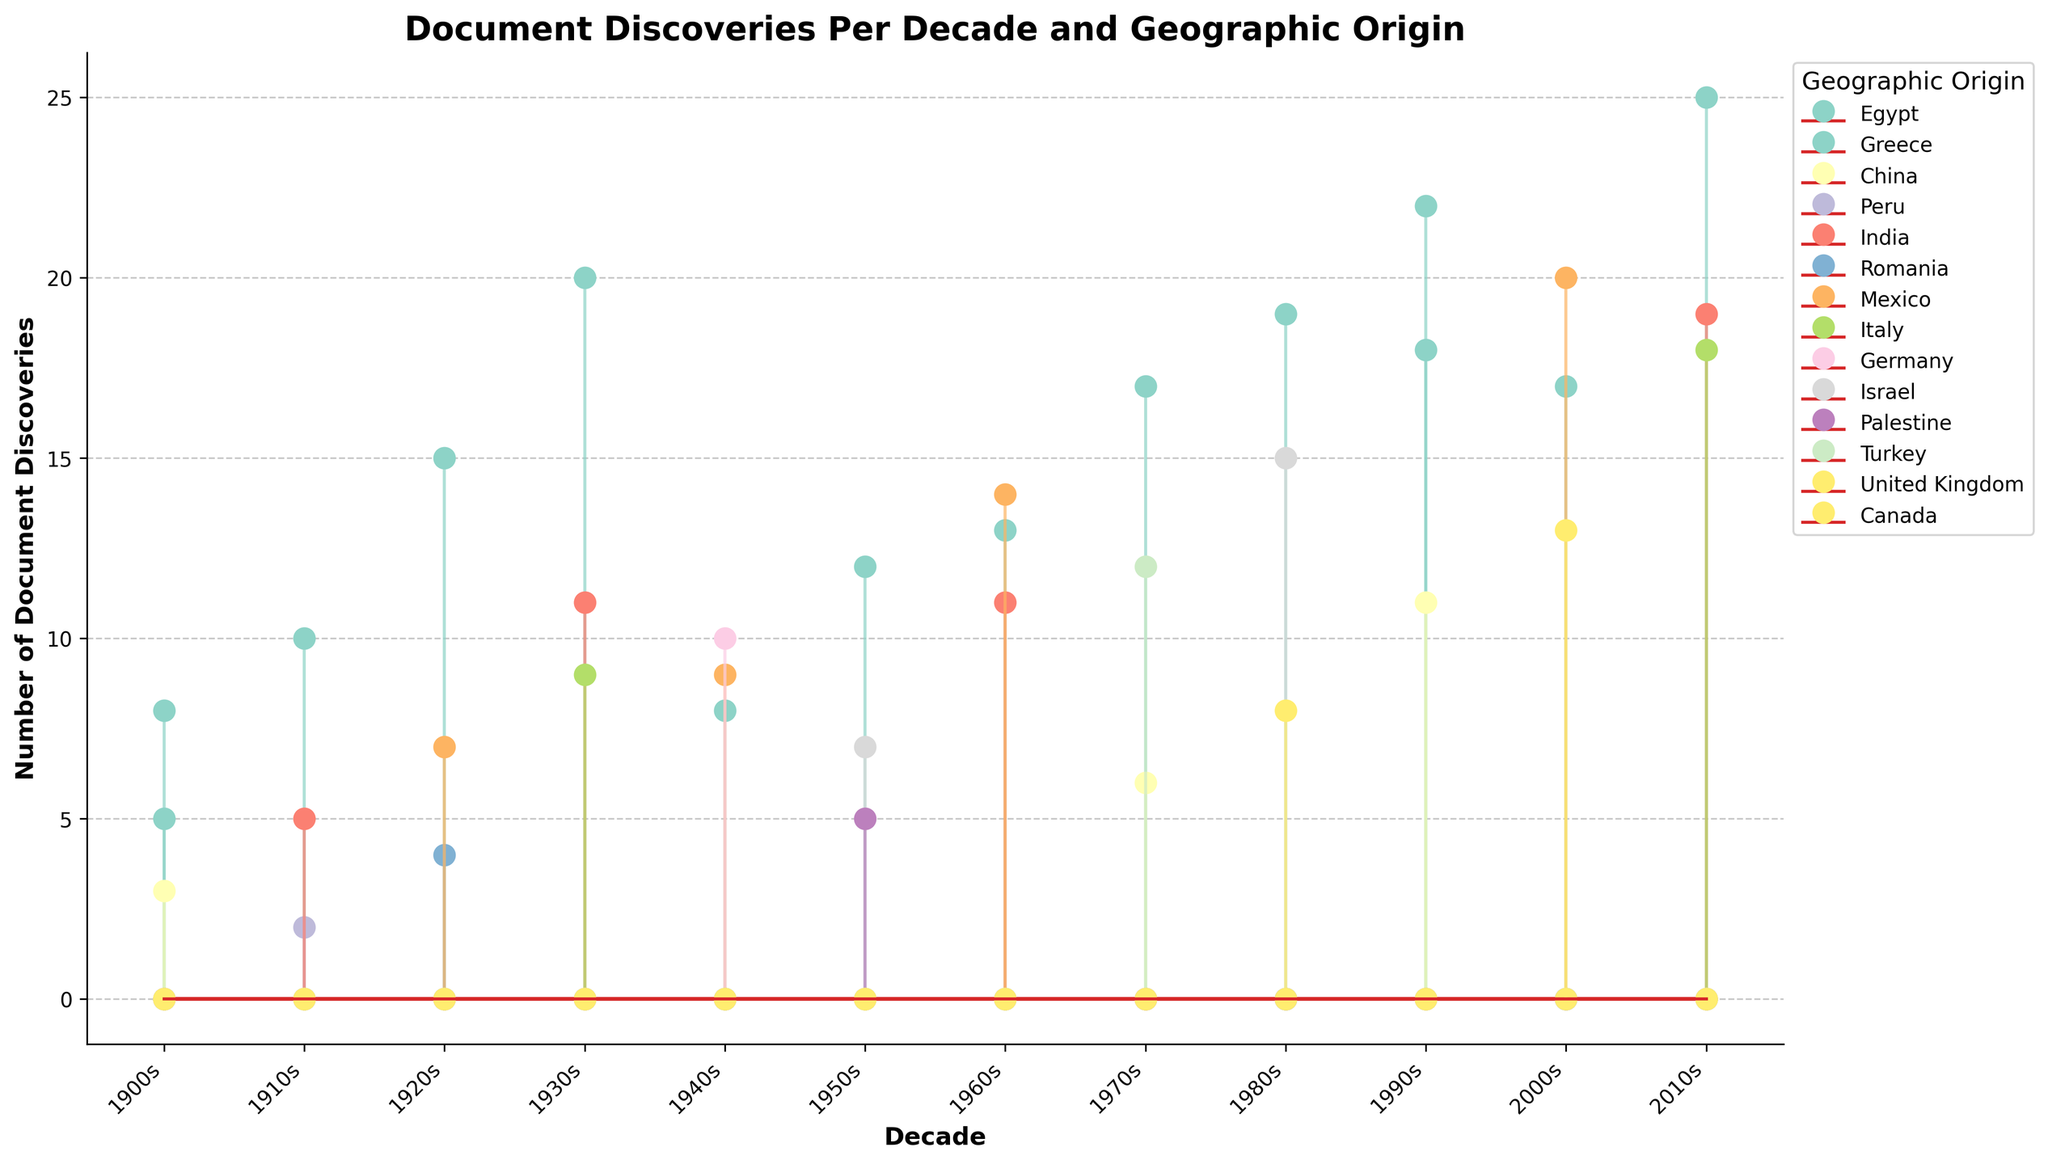When was the highest number of document discoveries made? The highest number of document discoveries is found by looking at the tallest stem across all decades. The tallest stem corresponds to the 2010s.
Answer: 2010s Which geographic origin had the most document discoveries in the 1980s? To find the origin with the most discoveries in the 1980s, observe the stems for the 1980s and identify the highest stem. The highest stem in the 1980s belongs to Egypt.
Answer: Egypt How many document discoveries were found in Egypt in the 1990s? To determine the number of document discoveries in Egypt in the 1990s, look at the specific stem for Egypt in the 1990s. The height of the stem indicates 22 discoveries.
Answer: 22 Which decade saw a greater number of discoveries in Mexico, the 1940s or the 1960s? Compare the height of the stems for Mexico in the 1940s and the 1960s. The 1960s has a higher stem for Mexico (14) compared to the 1940s (9).
Answer: 1960s How many geographic origins are represented in the 1920s? Count the number of different colored stems for the 1920s. There are four origins represented: Egypt, Romania, Mexico, and Greece.
Answer: 4 What is the total number of document discoveries in the 2000s? Sum the heights of all stems in the 2000s. Adding discoveries from Egypt (17), Mexico (20), and Canada (13) results in 50 total discoveries.
Answer: 50 Which geographic origin contributed the least number of document discoveries in the 1910s? Identify the shortest stem for the 1910s. Peru has the shortest stem with 2 discoveries.
Answer: Peru Observing the trend, which geographic origin seems to have a steadily increasing number of discoveries each decade? Examine the pattern of stems across decades for each origin. Egypt shows a general increasing trend (e.g., 20 in the 1930s, 25 in the 2010s).
Answer: Egypt By how much did the number of document discoveries in India change from the 1910s to the 2010s? Calculate the difference in the stem height for India between the 1910s (5) and the 2010s (19). The change is 19 - 5 = 14.
Answer: 14 